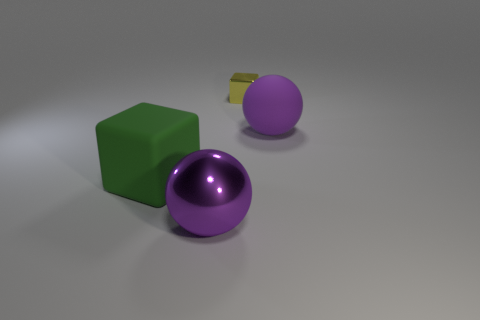Does the large metallic ball have the same color as the rubber sphere?
Offer a terse response. Yes. Are there any tiny shiny blocks behind the metallic object on the right side of the big purple ball on the left side of the yellow block?
Keep it short and to the point. No. There is a purple matte thing that is the same size as the purple shiny sphere; what is its shape?
Keep it short and to the point. Sphere. What is the color of the large rubber thing that is the same shape as the tiny metal object?
Your answer should be compact. Green. How many things are either cyan matte spheres or large rubber cubes?
Make the answer very short. 1. Do the large purple object in front of the large green object and the big object behind the green matte cube have the same shape?
Offer a terse response. Yes. There is a metal object that is behind the big shiny object; what shape is it?
Offer a terse response. Cube. Are there an equal number of big balls in front of the big purple metal object and large matte balls on the left side of the yellow metallic thing?
Keep it short and to the point. Yes. How many objects are either small metal cubes or things that are in front of the big green block?
Offer a terse response. 2. The object that is in front of the tiny yellow metallic block and behind the rubber cube has what shape?
Keep it short and to the point. Sphere. 